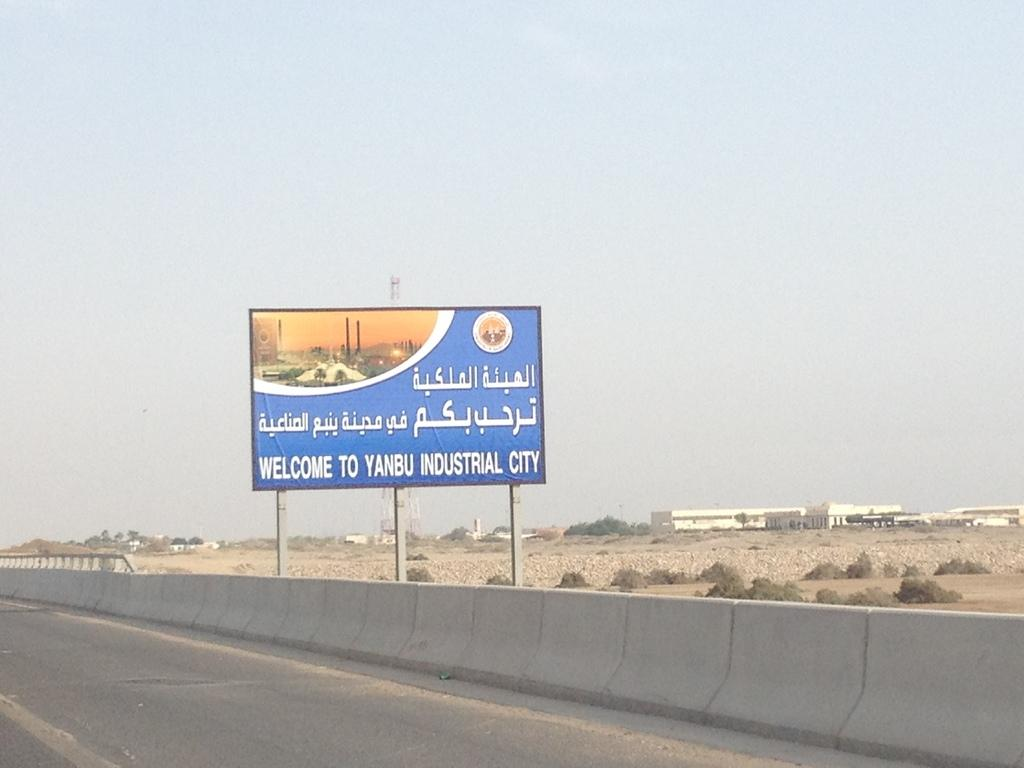Provide a one-sentence caption for the provided image. A sign is welcoming people to Yanbu Industrial City. 